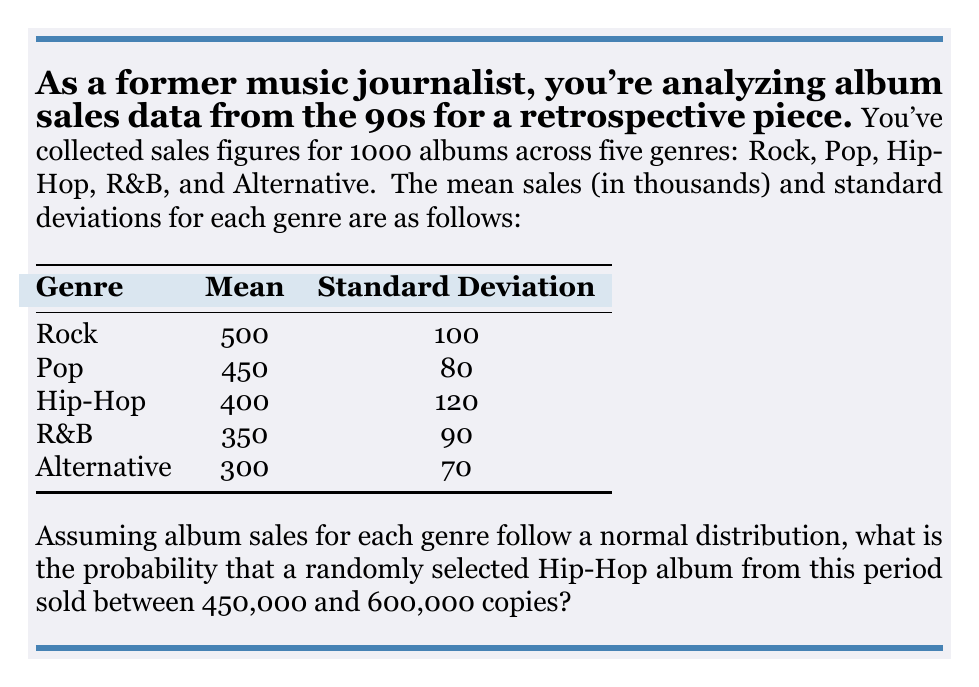Can you answer this question? To solve this problem, we'll use the properties of the normal distribution and the z-score formula. Let's break it down step-by-step:

1) We're dealing with the Hip-Hop genre, which has:
   Mean (μ) = 400,000
   Standard Deviation (σ) = 120,000

2) We need to find P(450,000 < X < 600,000), where X is the sales of a randomly selected Hip-Hop album.

3) To use the standard normal distribution table, we need to convert these values to z-scores:

   For 450,000: $z_1 = \frac{450,000 - 400,000}{120,000} = \frac{50,000}{120,000} = 0.4167$

   For 600,000: $z_2 = \frac{600,000 - 400,000}{120,000} = \frac{200,000}{120,000} = 1.6667$

4) Now, we need to find P(0.4167 < Z < 1.6667) in the standard normal distribution.

5) Using a standard normal distribution table or calculator:
   P(Z < 1.6667) = 0.9522
   P(Z < 0.4167) = 0.6615

6) The probability we're looking for is the difference between these two:
   P(0.4167 < Z < 1.6667) = 0.9522 - 0.6615 = 0.2907

Therefore, the probability that a randomly selected Hip-Hop album from this period sold between 450,000 and 600,000 copies is approximately 0.2907 or 29.07%.
Answer: 0.2907 